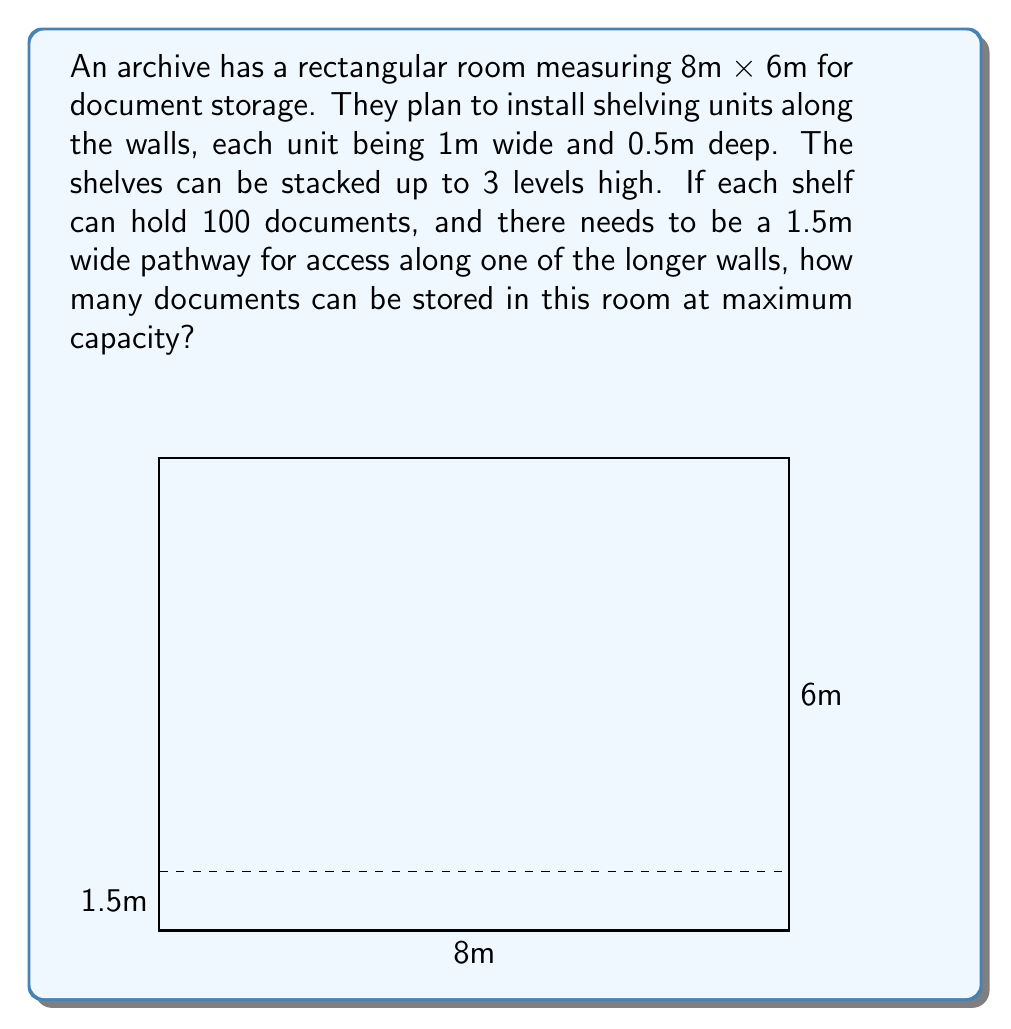Give your solution to this math problem. Let's approach this step-by-step:

1) First, we need to calculate the total wall length available for shelving:
   - Two long walls: $2 * 8\text{m} = 16\text{m}$
   - Two short walls: $2 * 6\text{m} = 12\text{m}$
   - Total: $16\text{m} + 12\text{m} = 28\text{m}$

2) However, we need to subtract the 1.5m pathway from one of the long walls:
   $28\text{m} - 1.5\text{m} = 26.5\text{m}$

3) Each shelf unit is 1m wide, so we can fit:
   $\lfloor 26.5 \div 1 \rfloor = 26$ shelf units
   (We use the floor function as we can't have partial shelf units)

4) Each shelf unit can be stacked 3 levels high, so total number of shelves:
   $26 * 3 = 78$ shelves

5) Each shelf can hold 100 documents, so total document capacity:
   $78 * 100 = 7,800$ documents

Therefore, the maximum number of documents that can be stored is 7,800.
Answer: 7,800 documents 